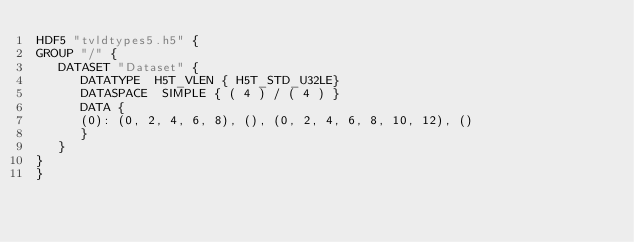Convert code to text. <code><loc_0><loc_0><loc_500><loc_500><_SQL_>HDF5 "tvldtypes5.h5" {
GROUP "/" {
   DATASET "Dataset" {
      DATATYPE  H5T_VLEN { H5T_STD_U32LE}
      DATASPACE  SIMPLE { ( 4 ) / ( 4 ) }
      DATA {
      (0): (0, 2, 4, 6, 8), (), (0, 2, 4, 6, 8, 10, 12), ()
      }
   }
}
}
</code> 